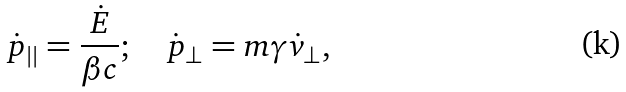<formula> <loc_0><loc_0><loc_500><loc_500>\dot { p } _ { | | } = \frac { \dot { E } } { \beta c } ; \quad \dot { p } _ { \perp } = m \gamma \dot { v } _ { \perp } ,</formula> 